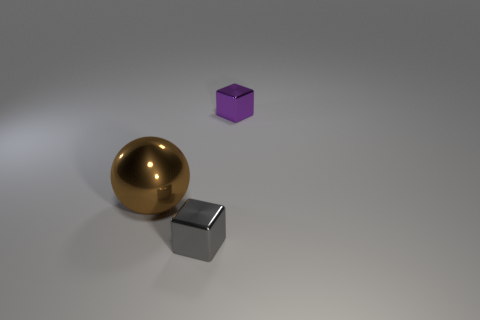What size is the purple cube right of the shiny cube to the left of the small metal cube that is behind the metal ball?
Your response must be concise. Small. What number of other things are the same size as the gray shiny block?
Your response must be concise. 1. What number of other large balls have the same material as the ball?
Give a very brief answer. 0. The thing in front of the big brown sphere has what shape?
Make the answer very short. Cube. Does the large brown object have the same material as the small thing that is on the left side of the tiny purple shiny object?
Provide a short and direct response. Yes. Is there a small cube?
Ensure brevity in your answer.  Yes. There is a big metallic ball to the left of the small object in front of the metallic sphere; is there a block that is behind it?
Offer a very short reply. Yes. How many small objects are metal blocks or green rubber cylinders?
Offer a terse response. 2. There is another cube that is the same size as the purple metal cube; what is its color?
Keep it short and to the point. Gray. There is a big object; how many blocks are in front of it?
Your answer should be compact. 1. 